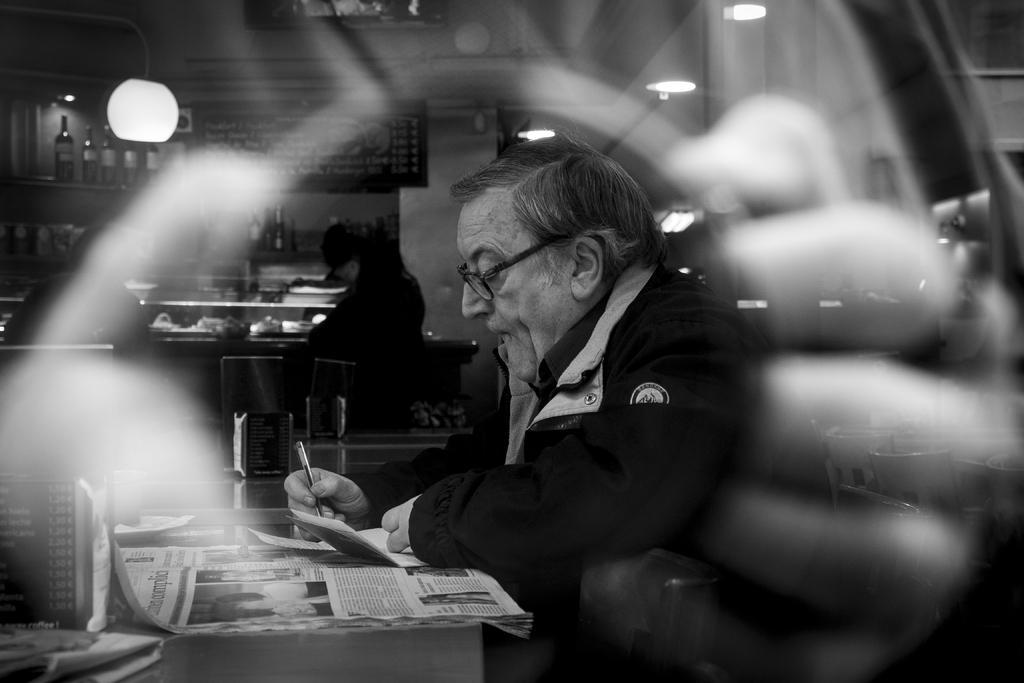Please provide a concise description of this image. In this image I can see a man wearing a jacket and specs. I can see him writing something on a paper. I can also see a newspaper in front of him. In the background I can see few more people and number of bottles on the shelf. 